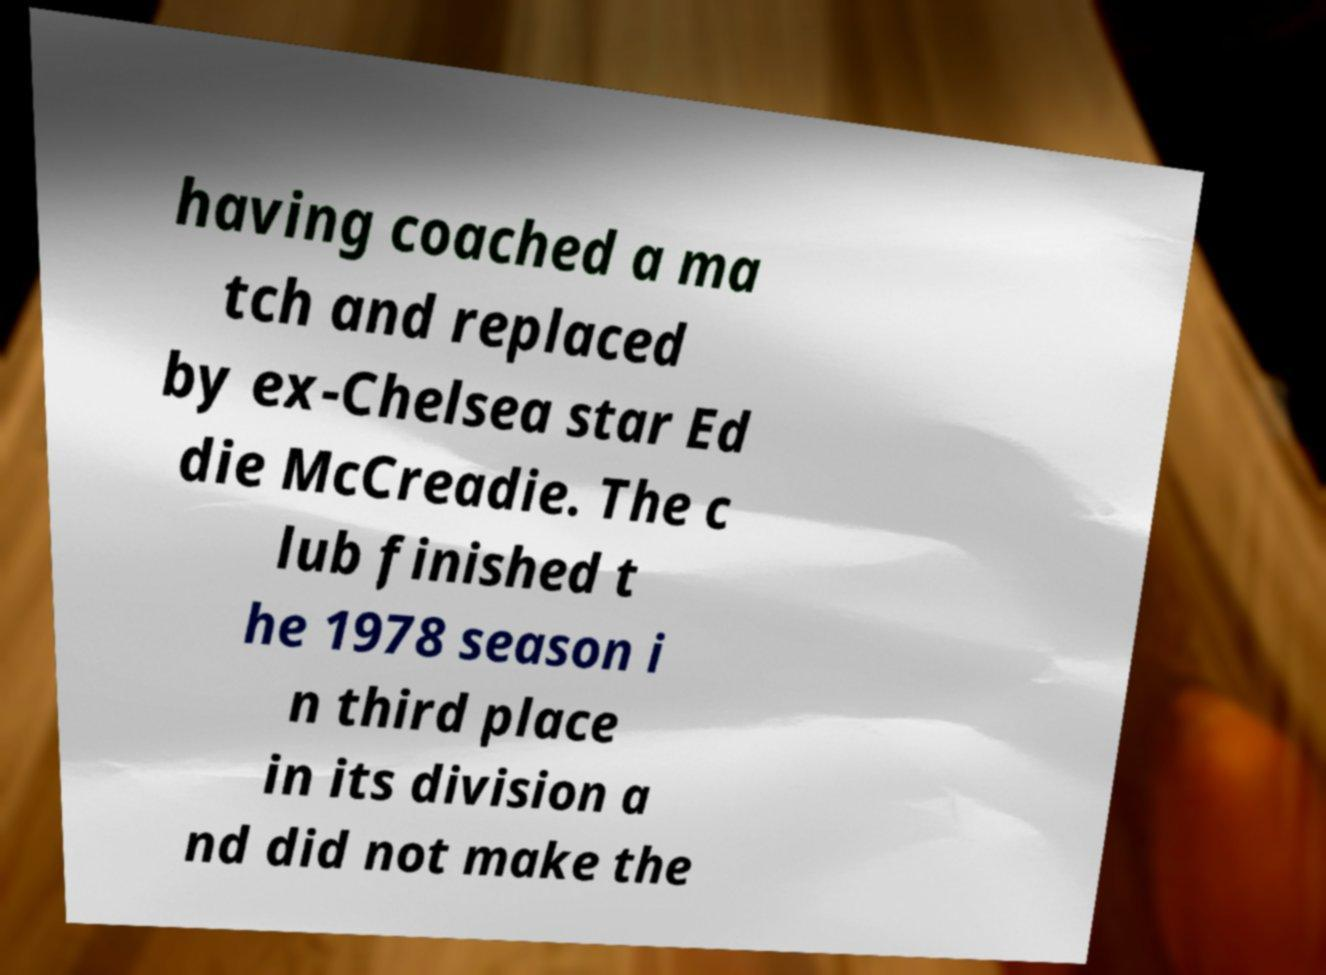Can you accurately transcribe the text from the provided image for me? having coached a ma tch and replaced by ex-Chelsea star Ed die McCreadie. The c lub finished t he 1978 season i n third place in its division a nd did not make the 